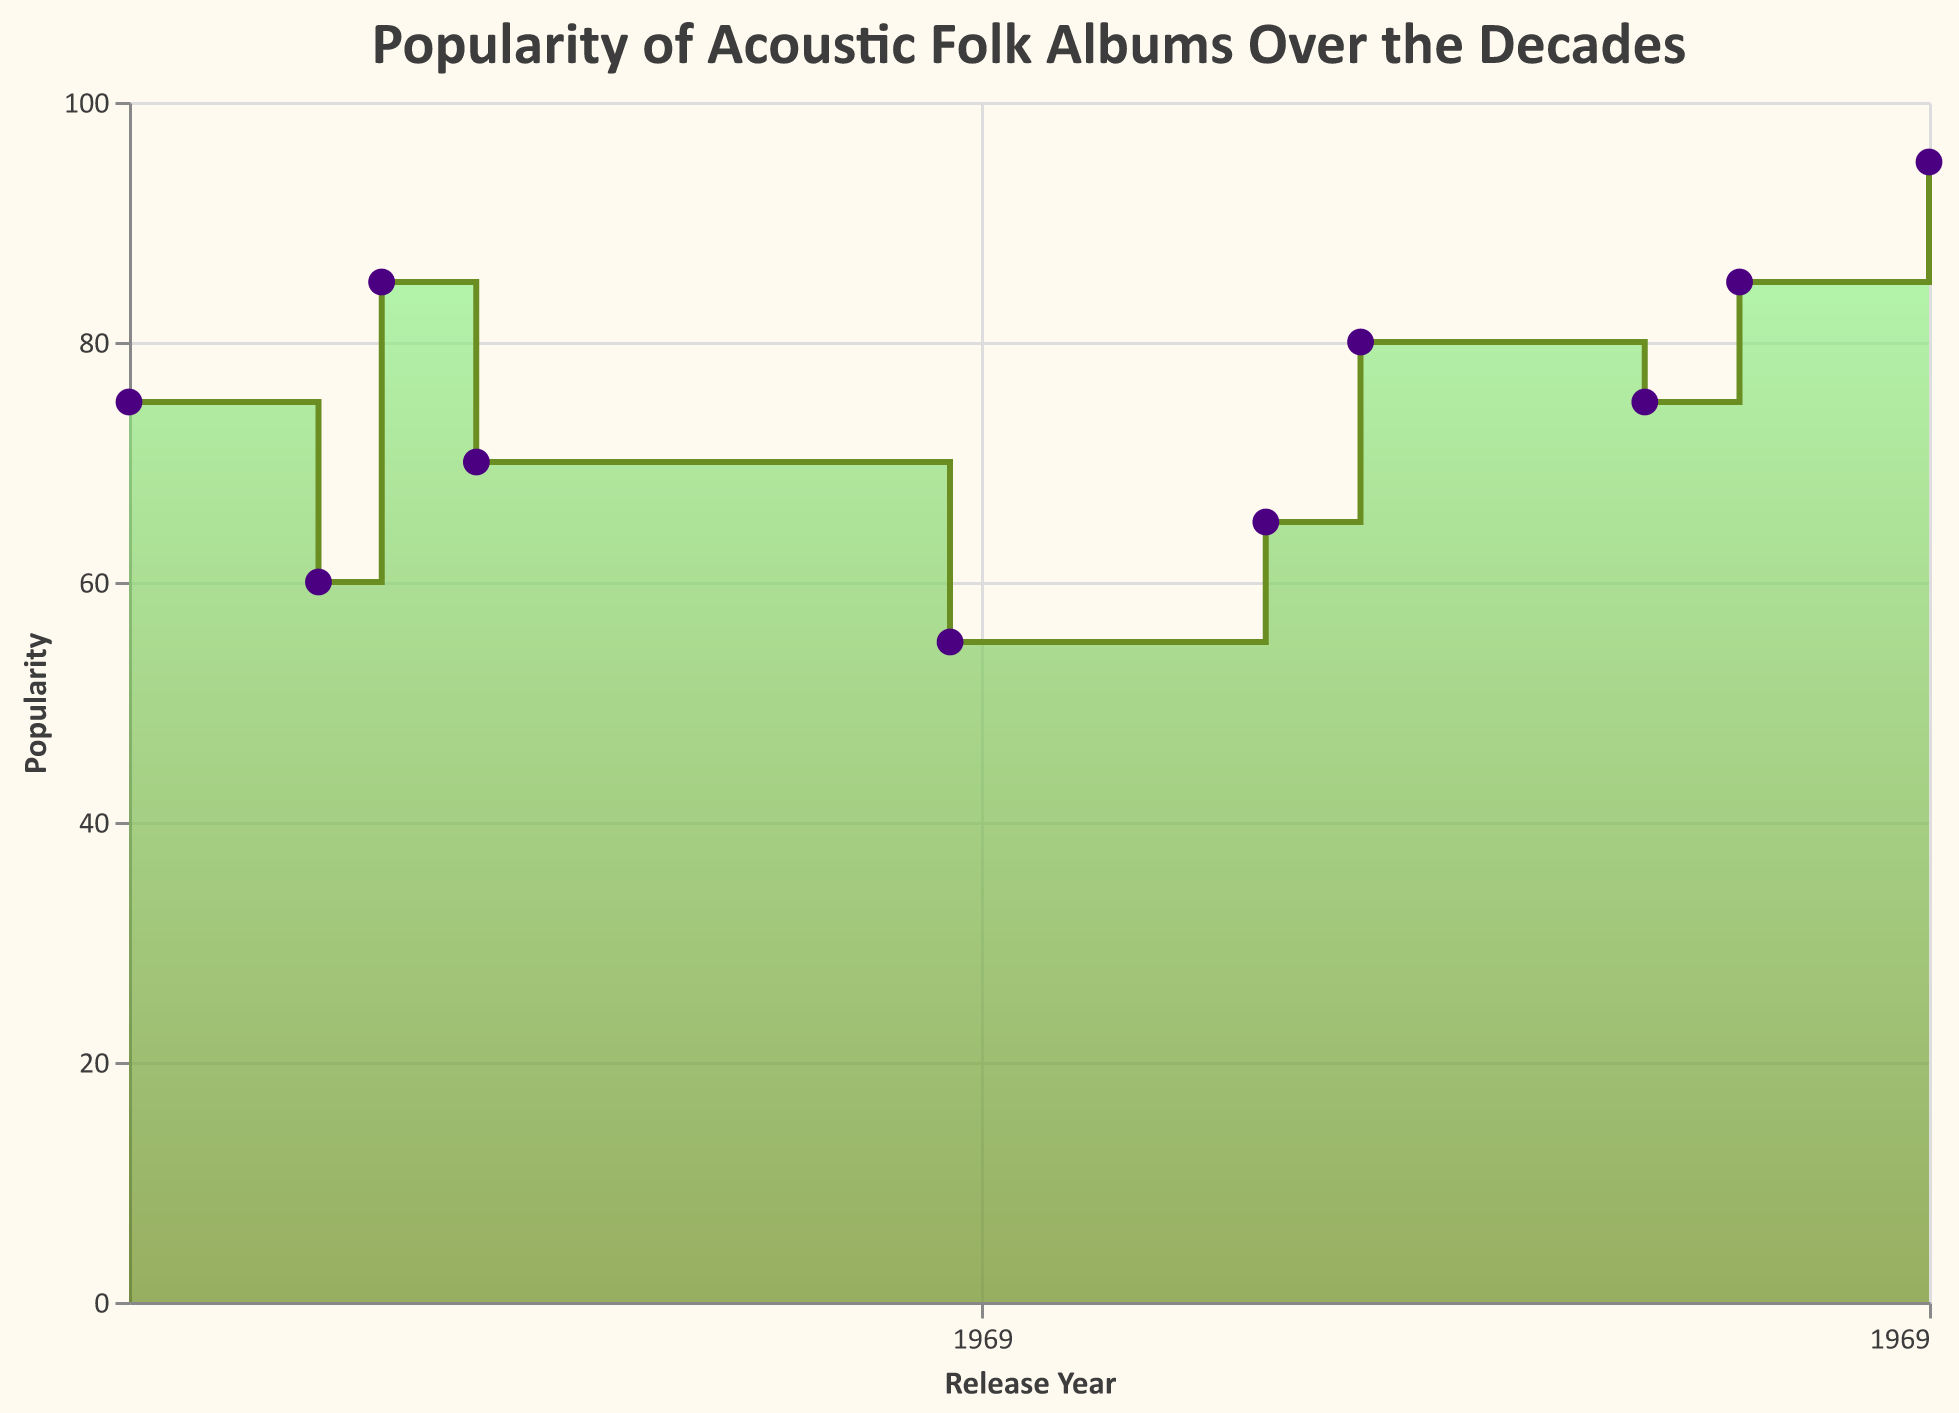what is the title of the chart? The title of the chart is written at the top, it reads "Popularity of Acoustic Folk Albums Over the Decades", indicating that it shows the popularity trends of acoustic folk albums across different decades.
Answer: Popularity of Acoustic Folk Albums Over the Decades What is the highest popularity score represented on the chart? The highest popularity score can be visually identified as the peak point in the step area curve. On the chart, this point is labeled with a score of 95, corresponding to the album "folklore" by Taylor Swift.
Answer: 95 Which album is marked with the highest popularity in the 1970s? To identify the album with the highest popularity score in the 1970s, look at the year segments within the 1970s range on the x-axis and find the peak point. The album "Blue" by Joni Mitchell released in 1971 has the highest popularity score of 85 in that decade.
Answer: Blue How many major album releases are highlighted in the 2010s? To determine the number of major releases highlighted in the 2010s, count the distinct points within the 2010s segment on the x-axis. There are two highlighted points: "The Harrow & The Harvest" by Gillian Welch in 2011, and "Lost in the Dream" by The War on Drugs in 2014.
Answer: 2 What can you say about the trend of album popularity from the 1980s to the 1990s? Analyze the segment of the chart from the 1980s to the end of the 1990s. The popularity shows a slight increase, starting at 55 with "Infamous Angel" in 1989 and rising to 65 with "Every Kind of Light" in 1999.
Answer: Slight increase Between which two points does the biggest leap in popularity occur? Examine the chart for the steepest increase between two consecutive points. The biggest leap occurs between the 2014 release of "Lost in the Dream" with a popularity of 85 and the 2020 release of "folklore" with a popularity of 95.
Answer: Between 2014 and 2020 What is the average popularity of albums released in the 1960s? Locate the popularity points for the albums in the 1960s and calculate their average. The two albums are "The Freewheelin' Bob Dylan" with a score of 75 and "Five Leaves Left" with a score of 60. The average is (75 + 60) / 2 = 67.5.
Answer: 67.5 Which decade experienced the most fluctuation in popularity? Identify the decade where the popularity scores vary the most. The 2010s show the most fluctuation, with "The Harrow & The Harvest" at 75 and "Lost in the Dream" at 85.
Answer: 2010s Does the overall trend show an increase or decrease in popularity from the 1960s to the 2020s? Analyze the general direction of the step area chart from the leftmost data point in the 1960s to the rightmost data point in the 2020s. The overall trend shows an increase, as the popularity rises from 75 in the 1960s to 95 in the 2020s.
Answer: Increase 